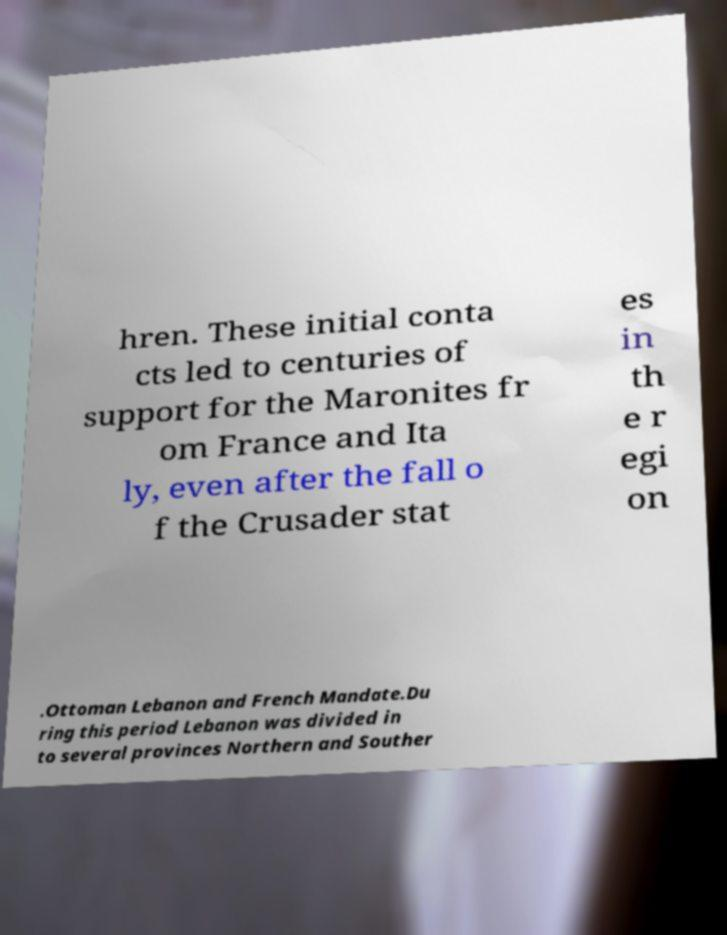Could you extract and type out the text from this image? hren. These initial conta cts led to centuries of support for the Maronites fr om France and Ita ly, even after the fall o f the Crusader stat es in th e r egi on .Ottoman Lebanon and French Mandate.Du ring this period Lebanon was divided in to several provinces Northern and Souther 